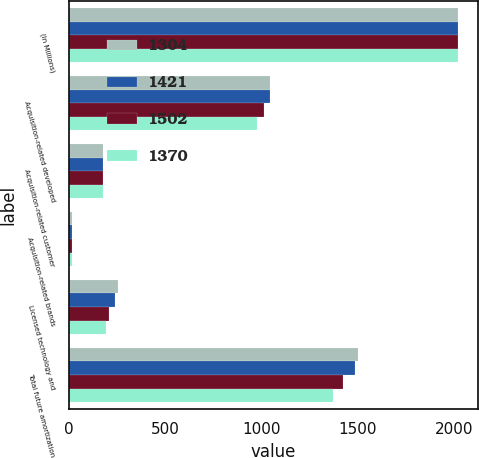Convert chart to OTSL. <chart><loc_0><loc_0><loc_500><loc_500><stacked_bar_chart><ecel><fcel>(In Millions)<fcel>Acquisition-related developed<fcel>Acquisition-related customer<fcel>Acquisition-related brands<fcel>Licensed technology and<fcel>Total future amortization<nl><fcel>1304<fcel>2018<fcel>1045<fcel>181<fcel>20<fcel>256<fcel>1502<nl><fcel>1421<fcel>2019<fcel>1043<fcel>180<fcel>20<fcel>243<fcel>1486<nl><fcel>1502<fcel>2020<fcel>1011<fcel>179<fcel>20<fcel>211<fcel>1421<nl><fcel>1370<fcel>2021<fcel>976<fcel>179<fcel>20<fcel>195<fcel>1370<nl></chart> 